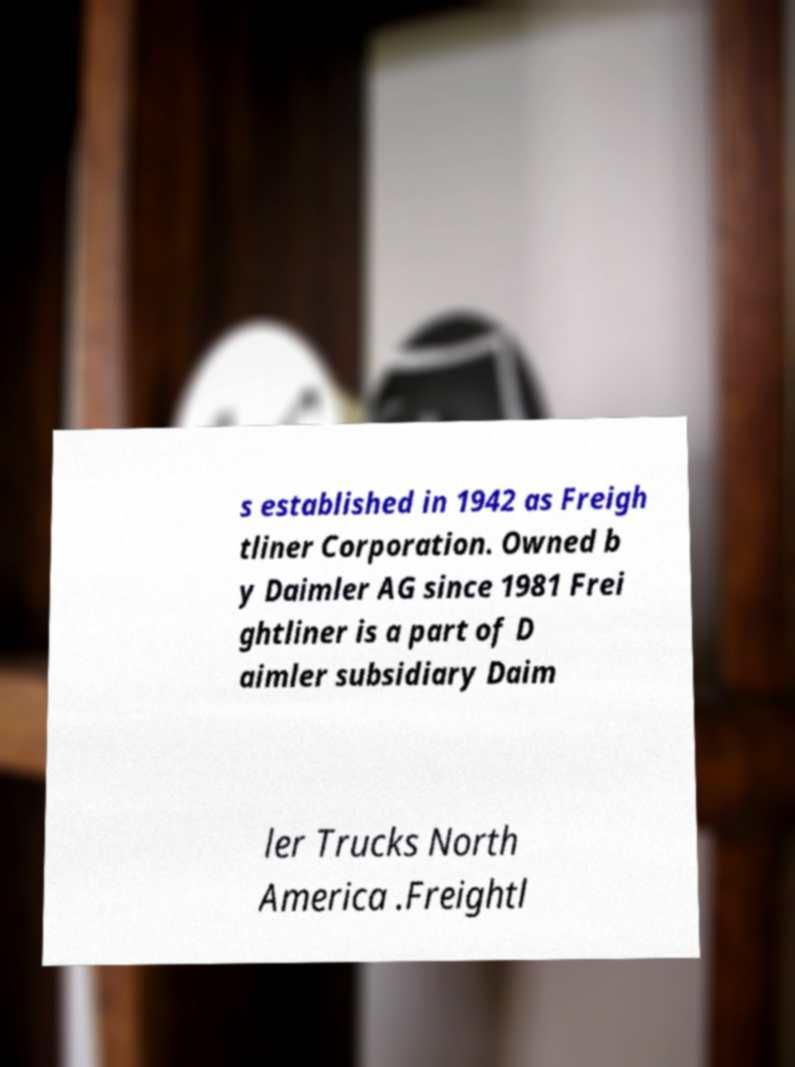For documentation purposes, I need the text within this image transcribed. Could you provide that? s established in 1942 as Freigh tliner Corporation. Owned b y Daimler AG since 1981 Frei ghtliner is a part of D aimler subsidiary Daim ler Trucks North America .Freightl 